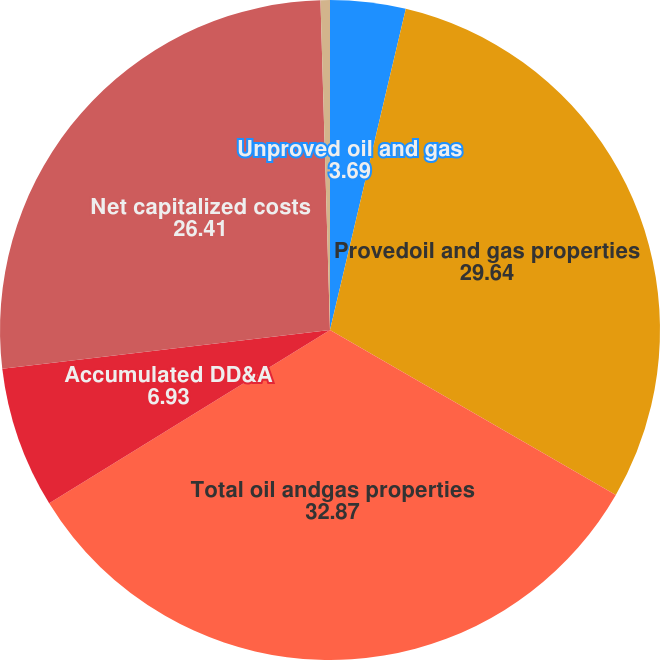<chart> <loc_0><loc_0><loc_500><loc_500><pie_chart><fcel>Unproved oil and gas<fcel>Provedoil and gas properties<fcel>Total oil andgas properties<fcel>Accumulated DD&A<fcel>Net capitalized costs<fcel>Company'sshare of Alba Plant<nl><fcel>3.69%<fcel>29.64%<fcel>32.87%<fcel>6.93%<fcel>26.41%<fcel>0.46%<nl></chart> 